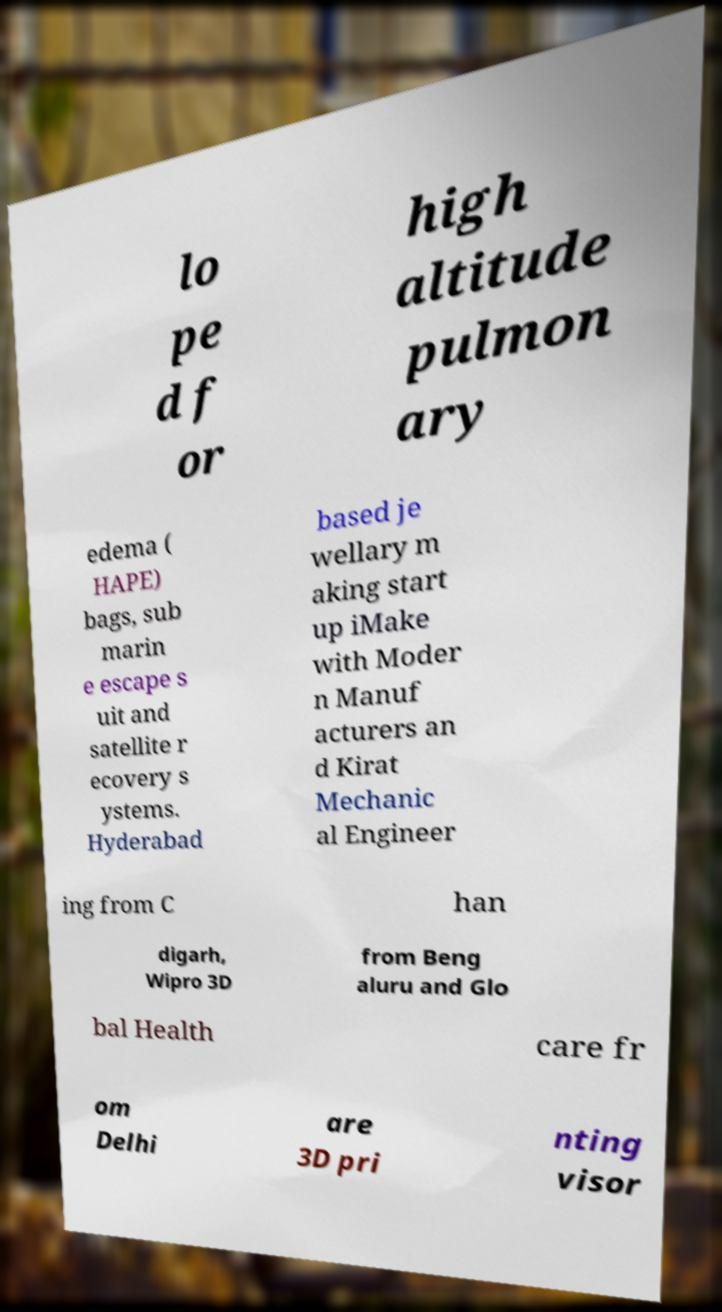Please read and relay the text visible in this image. What does it say? lo pe d f or high altitude pulmon ary edema ( HAPE) bags, sub marin e escape s uit and satellite r ecovery s ystems. Hyderabad based je wellary m aking start up iMake with Moder n Manuf acturers an d Kirat Mechanic al Engineer ing from C han digarh, Wipro 3D from Beng aluru and Glo bal Health care fr om Delhi are 3D pri nting visor 